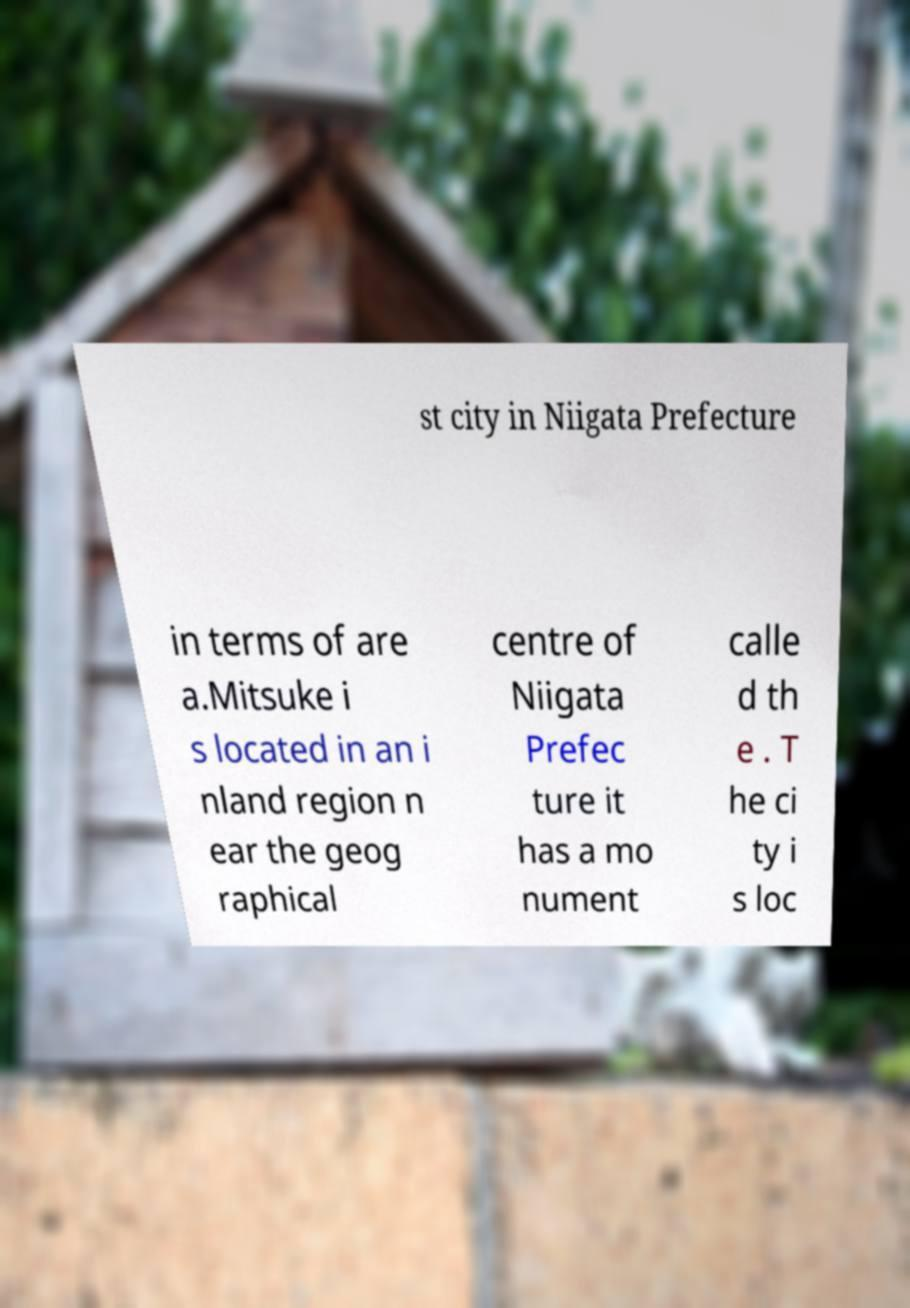For documentation purposes, I need the text within this image transcribed. Could you provide that? st city in Niigata Prefecture in terms of are a.Mitsuke i s located in an i nland region n ear the geog raphical centre of Niigata Prefec ture it has a mo nument calle d th e . T he ci ty i s loc 